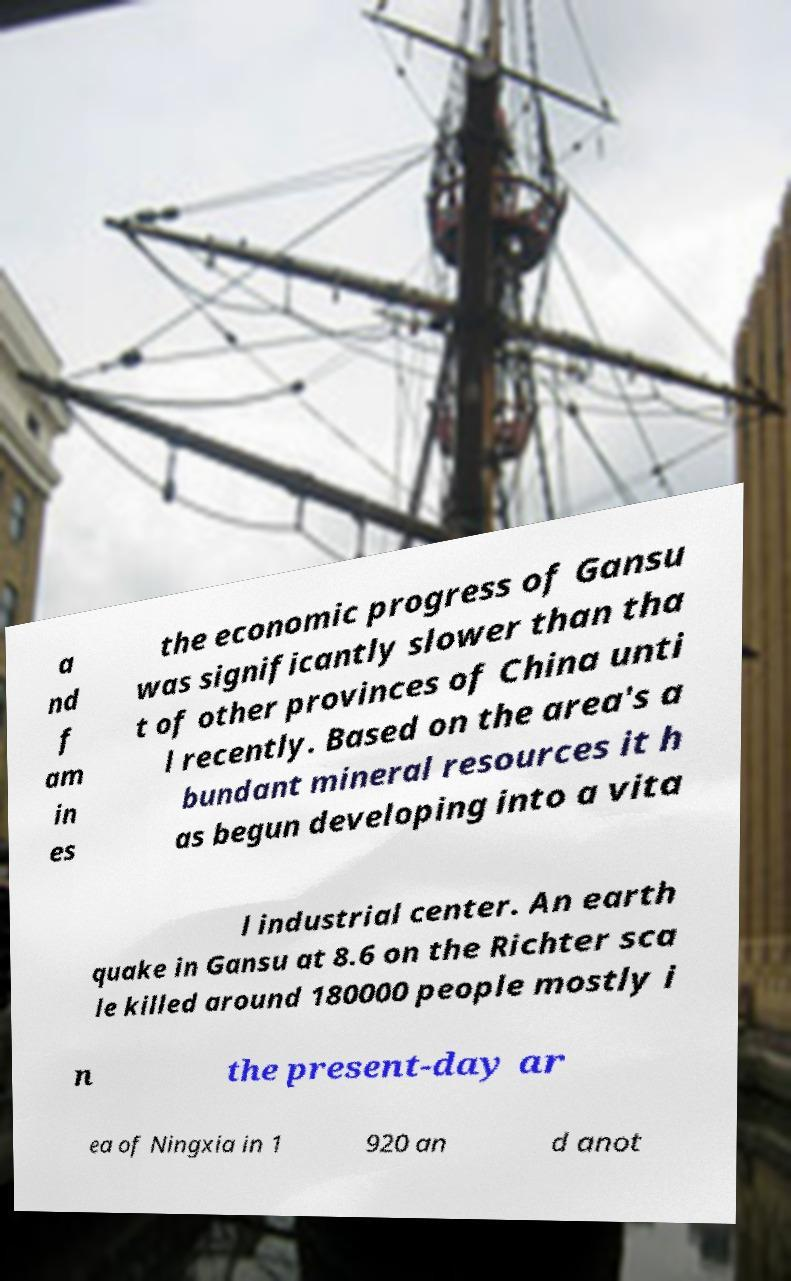What messages or text are displayed in this image? I need them in a readable, typed format. a nd f am in es the economic progress of Gansu was significantly slower than tha t of other provinces of China unti l recently. Based on the area's a bundant mineral resources it h as begun developing into a vita l industrial center. An earth quake in Gansu at 8.6 on the Richter sca le killed around 180000 people mostly i n the present-day ar ea of Ningxia in 1 920 an d anot 